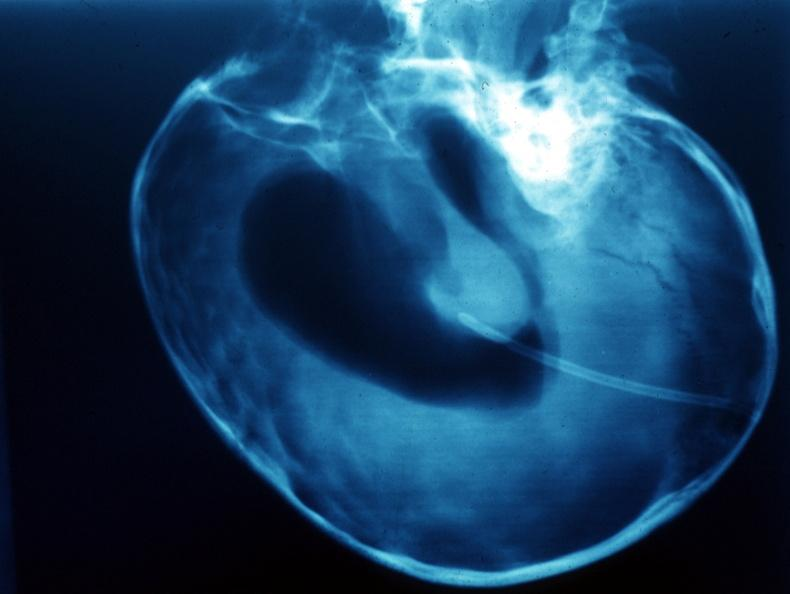what is present?
Answer the question using a single word or phrase. Brain 